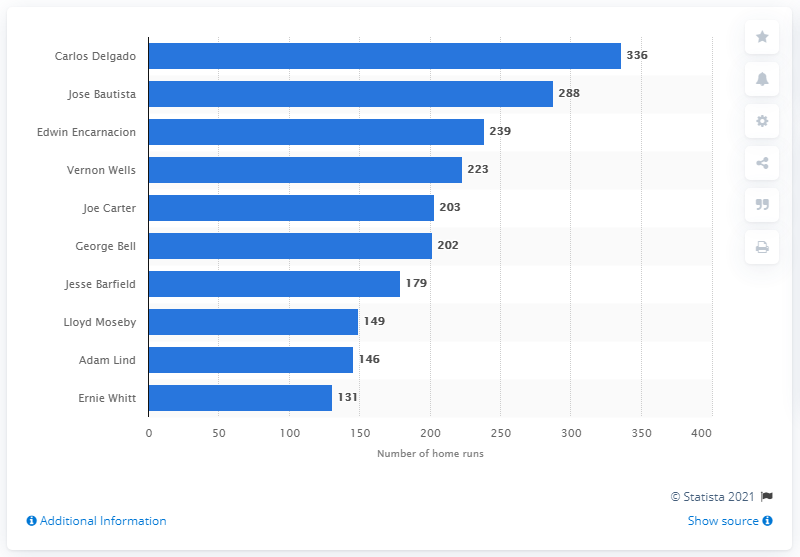List a handful of essential elements in this visual. The Toronto Blue Jays franchise has seen many players hit home runs, but none have hit more than Carlos Delgado. Carlos Delgado has hit 336 home runs. 